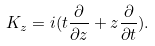<formula> <loc_0><loc_0><loc_500><loc_500>K _ { z } = i ( t \frac { \partial } { \partial z } + z \frac { \partial } { \partial t } ) .</formula> 